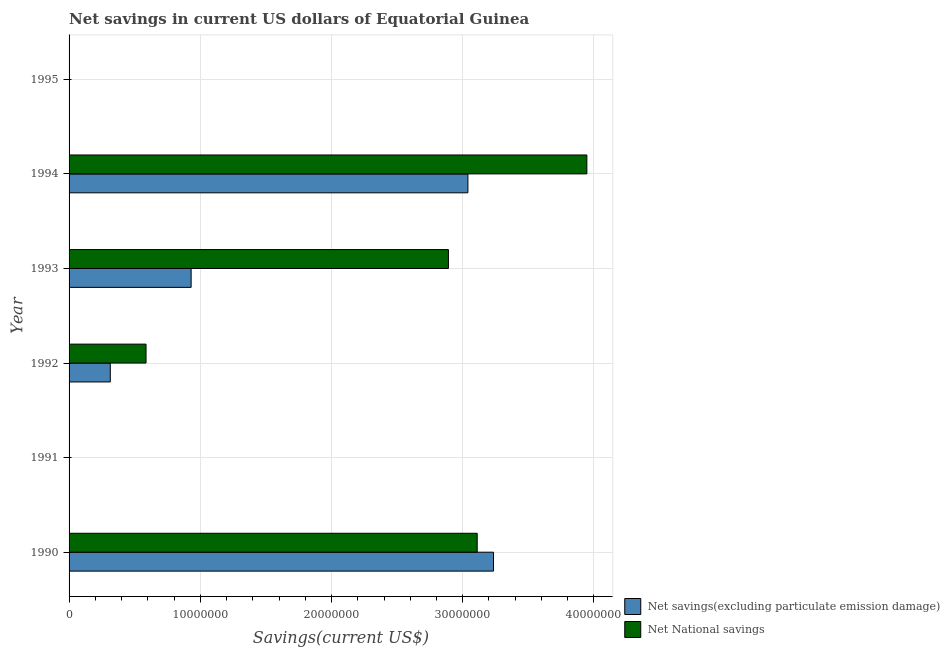How many different coloured bars are there?
Provide a succinct answer. 2. Are the number of bars per tick equal to the number of legend labels?
Offer a terse response. No. Are the number of bars on each tick of the Y-axis equal?
Ensure brevity in your answer.  No. How many bars are there on the 1st tick from the bottom?
Your response must be concise. 2. What is the net national savings in 1993?
Offer a very short reply. 2.89e+07. Across all years, what is the maximum net national savings?
Give a very brief answer. 3.95e+07. What is the total net savings(excluding particulate emission damage) in the graph?
Ensure brevity in your answer.  7.52e+07. What is the difference between the net national savings in 1992 and that in 1994?
Ensure brevity in your answer.  -3.36e+07. What is the difference between the net savings(excluding particulate emission damage) in 1991 and the net national savings in 1994?
Offer a very short reply. -3.95e+07. What is the average net national savings per year?
Make the answer very short. 1.76e+07. In the year 1992, what is the difference between the net savings(excluding particulate emission damage) and net national savings?
Give a very brief answer. -2.72e+06. In how many years, is the net savings(excluding particulate emission damage) greater than 6000000 US$?
Make the answer very short. 3. What is the ratio of the net savings(excluding particulate emission damage) in 1990 to that in 1993?
Provide a short and direct response. 3.48. Is the difference between the net savings(excluding particulate emission damage) in 1993 and 1994 greater than the difference between the net national savings in 1993 and 1994?
Your answer should be very brief. No. What is the difference between the highest and the second highest net national savings?
Ensure brevity in your answer.  8.36e+06. What is the difference between the highest and the lowest net national savings?
Provide a succinct answer. 3.95e+07. Are all the bars in the graph horizontal?
Provide a short and direct response. Yes. Are the values on the major ticks of X-axis written in scientific E-notation?
Provide a short and direct response. No. Does the graph contain any zero values?
Offer a terse response. Yes. How many legend labels are there?
Make the answer very short. 2. How are the legend labels stacked?
Make the answer very short. Vertical. What is the title of the graph?
Your response must be concise. Net savings in current US dollars of Equatorial Guinea. Does "From World Bank" appear as one of the legend labels in the graph?
Give a very brief answer. No. What is the label or title of the X-axis?
Keep it short and to the point. Savings(current US$). What is the Savings(current US$) in Net savings(excluding particulate emission damage) in 1990?
Offer a very short reply. 3.23e+07. What is the Savings(current US$) of Net National savings in 1990?
Offer a terse response. 3.11e+07. What is the Savings(current US$) of Net savings(excluding particulate emission damage) in 1992?
Your answer should be compact. 3.14e+06. What is the Savings(current US$) of Net National savings in 1992?
Your answer should be very brief. 5.87e+06. What is the Savings(current US$) in Net savings(excluding particulate emission damage) in 1993?
Ensure brevity in your answer.  9.30e+06. What is the Savings(current US$) of Net National savings in 1993?
Ensure brevity in your answer.  2.89e+07. What is the Savings(current US$) in Net savings(excluding particulate emission damage) in 1994?
Offer a terse response. 3.04e+07. What is the Savings(current US$) in Net National savings in 1994?
Offer a very short reply. 3.95e+07. Across all years, what is the maximum Savings(current US$) of Net savings(excluding particulate emission damage)?
Provide a succinct answer. 3.23e+07. Across all years, what is the maximum Savings(current US$) of Net National savings?
Your response must be concise. 3.95e+07. What is the total Savings(current US$) in Net savings(excluding particulate emission damage) in the graph?
Your answer should be very brief. 7.52e+07. What is the total Savings(current US$) in Net National savings in the graph?
Make the answer very short. 1.05e+08. What is the difference between the Savings(current US$) in Net savings(excluding particulate emission damage) in 1990 and that in 1992?
Offer a very short reply. 2.92e+07. What is the difference between the Savings(current US$) of Net National savings in 1990 and that in 1992?
Provide a short and direct response. 2.52e+07. What is the difference between the Savings(current US$) of Net savings(excluding particulate emission damage) in 1990 and that in 1993?
Provide a short and direct response. 2.30e+07. What is the difference between the Savings(current US$) of Net National savings in 1990 and that in 1993?
Keep it short and to the point. 2.19e+06. What is the difference between the Savings(current US$) in Net savings(excluding particulate emission damage) in 1990 and that in 1994?
Your answer should be very brief. 1.95e+06. What is the difference between the Savings(current US$) of Net National savings in 1990 and that in 1994?
Ensure brevity in your answer.  -8.36e+06. What is the difference between the Savings(current US$) in Net savings(excluding particulate emission damage) in 1992 and that in 1993?
Provide a short and direct response. -6.16e+06. What is the difference between the Savings(current US$) of Net National savings in 1992 and that in 1993?
Give a very brief answer. -2.30e+07. What is the difference between the Savings(current US$) of Net savings(excluding particulate emission damage) in 1992 and that in 1994?
Keep it short and to the point. -2.73e+07. What is the difference between the Savings(current US$) in Net National savings in 1992 and that in 1994?
Give a very brief answer. -3.36e+07. What is the difference between the Savings(current US$) in Net savings(excluding particulate emission damage) in 1993 and that in 1994?
Give a very brief answer. -2.11e+07. What is the difference between the Savings(current US$) in Net National savings in 1993 and that in 1994?
Offer a very short reply. -1.05e+07. What is the difference between the Savings(current US$) of Net savings(excluding particulate emission damage) in 1990 and the Savings(current US$) of Net National savings in 1992?
Provide a succinct answer. 2.65e+07. What is the difference between the Savings(current US$) of Net savings(excluding particulate emission damage) in 1990 and the Savings(current US$) of Net National savings in 1993?
Offer a very short reply. 3.44e+06. What is the difference between the Savings(current US$) in Net savings(excluding particulate emission damage) in 1990 and the Savings(current US$) in Net National savings in 1994?
Your answer should be very brief. -7.11e+06. What is the difference between the Savings(current US$) of Net savings(excluding particulate emission damage) in 1992 and the Savings(current US$) of Net National savings in 1993?
Your response must be concise. -2.58e+07. What is the difference between the Savings(current US$) of Net savings(excluding particulate emission damage) in 1992 and the Savings(current US$) of Net National savings in 1994?
Your answer should be very brief. -3.63e+07. What is the difference between the Savings(current US$) in Net savings(excluding particulate emission damage) in 1993 and the Savings(current US$) in Net National savings in 1994?
Offer a very short reply. -3.02e+07. What is the average Savings(current US$) of Net savings(excluding particulate emission damage) per year?
Offer a terse response. 1.25e+07. What is the average Savings(current US$) of Net National savings per year?
Your response must be concise. 1.76e+07. In the year 1990, what is the difference between the Savings(current US$) of Net savings(excluding particulate emission damage) and Savings(current US$) of Net National savings?
Your response must be concise. 1.24e+06. In the year 1992, what is the difference between the Savings(current US$) in Net savings(excluding particulate emission damage) and Savings(current US$) in Net National savings?
Your answer should be compact. -2.72e+06. In the year 1993, what is the difference between the Savings(current US$) in Net savings(excluding particulate emission damage) and Savings(current US$) in Net National savings?
Provide a short and direct response. -1.96e+07. In the year 1994, what is the difference between the Savings(current US$) of Net savings(excluding particulate emission damage) and Savings(current US$) of Net National savings?
Provide a succinct answer. -9.07e+06. What is the ratio of the Savings(current US$) of Net savings(excluding particulate emission damage) in 1990 to that in 1992?
Your response must be concise. 10.3. What is the ratio of the Savings(current US$) in Net National savings in 1990 to that in 1992?
Keep it short and to the point. 5.3. What is the ratio of the Savings(current US$) of Net savings(excluding particulate emission damage) in 1990 to that in 1993?
Keep it short and to the point. 3.48. What is the ratio of the Savings(current US$) of Net National savings in 1990 to that in 1993?
Your response must be concise. 1.08. What is the ratio of the Savings(current US$) of Net savings(excluding particulate emission damage) in 1990 to that in 1994?
Offer a terse response. 1.06. What is the ratio of the Savings(current US$) of Net National savings in 1990 to that in 1994?
Give a very brief answer. 0.79. What is the ratio of the Savings(current US$) of Net savings(excluding particulate emission damage) in 1992 to that in 1993?
Your answer should be very brief. 0.34. What is the ratio of the Savings(current US$) in Net National savings in 1992 to that in 1993?
Make the answer very short. 0.2. What is the ratio of the Savings(current US$) in Net savings(excluding particulate emission damage) in 1992 to that in 1994?
Your response must be concise. 0.1. What is the ratio of the Savings(current US$) in Net National savings in 1992 to that in 1994?
Keep it short and to the point. 0.15. What is the ratio of the Savings(current US$) in Net savings(excluding particulate emission damage) in 1993 to that in 1994?
Ensure brevity in your answer.  0.31. What is the ratio of the Savings(current US$) of Net National savings in 1993 to that in 1994?
Give a very brief answer. 0.73. What is the difference between the highest and the second highest Savings(current US$) of Net savings(excluding particulate emission damage)?
Provide a succinct answer. 1.95e+06. What is the difference between the highest and the second highest Savings(current US$) in Net National savings?
Provide a short and direct response. 8.36e+06. What is the difference between the highest and the lowest Savings(current US$) in Net savings(excluding particulate emission damage)?
Keep it short and to the point. 3.23e+07. What is the difference between the highest and the lowest Savings(current US$) in Net National savings?
Provide a short and direct response. 3.95e+07. 